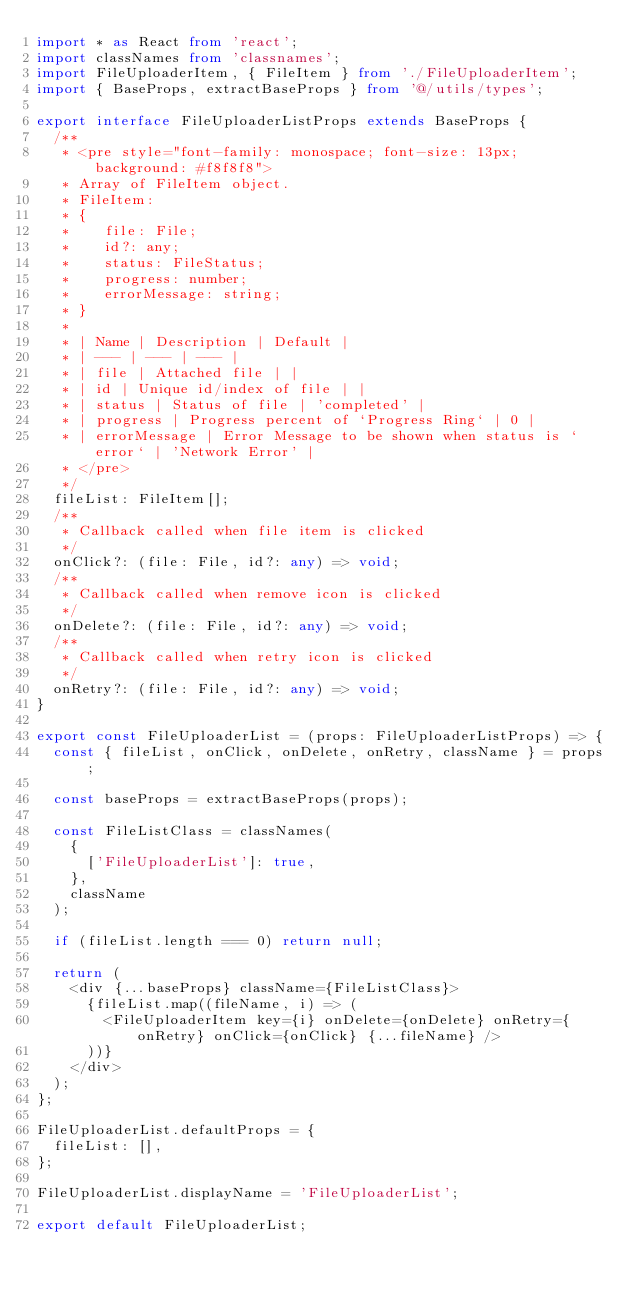<code> <loc_0><loc_0><loc_500><loc_500><_TypeScript_>import * as React from 'react';
import classNames from 'classnames';
import FileUploaderItem, { FileItem } from './FileUploaderItem';
import { BaseProps, extractBaseProps } from '@/utils/types';

export interface FileUploaderListProps extends BaseProps {
  /**
   * <pre style="font-family: monospace; font-size: 13px; background: #f8f8f8">
   * Array of FileItem object.
   * FileItem:
   * {
   *    file: File;
   *    id?: any;
   *    status: FileStatus;
   *    progress: number;
   *    errorMessage: string;
   * }
   *
   * | Name | Description | Default |
   * | --- | --- | --- |
   * | file | Attached file | |
   * | id | Unique id/index of file | |
   * | status | Status of file | 'completed' |
   * | progress | Progress percent of `Progress Ring` | 0 |
   * | errorMessage | Error Message to be shown when status is `error` | 'Network Error' |
   * </pre>
   */
  fileList: FileItem[];
  /**
   * Callback called when file item is clicked
   */
  onClick?: (file: File, id?: any) => void;
  /**
   * Callback called when remove icon is clicked
   */
  onDelete?: (file: File, id?: any) => void;
  /**
   * Callback called when retry icon is clicked
   */
  onRetry?: (file: File, id?: any) => void;
}

export const FileUploaderList = (props: FileUploaderListProps) => {
  const { fileList, onClick, onDelete, onRetry, className } = props;

  const baseProps = extractBaseProps(props);

  const FileListClass = classNames(
    {
      ['FileUploaderList']: true,
    },
    className
  );

  if (fileList.length === 0) return null;

  return (
    <div {...baseProps} className={FileListClass}>
      {fileList.map((fileName, i) => (
        <FileUploaderItem key={i} onDelete={onDelete} onRetry={onRetry} onClick={onClick} {...fileName} />
      ))}
    </div>
  );
};

FileUploaderList.defaultProps = {
  fileList: [],
};

FileUploaderList.displayName = 'FileUploaderList';

export default FileUploaderList;
</code> 